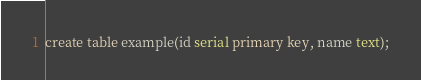<code> <loc_0><loc_0><loc_500><loc_500><_SQL_>
create table example(id serial primary key, name text);</code> 